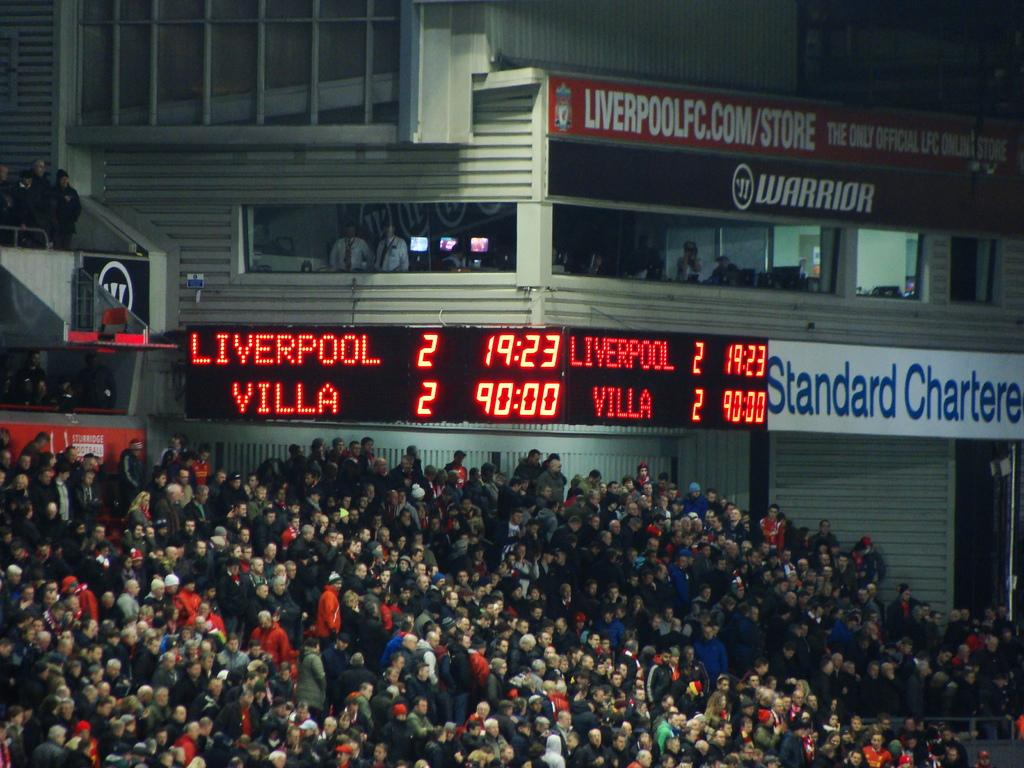<image>
Create a compact narrative representing the image presented. A football match between Liverpool and Villa which is at 2 all 